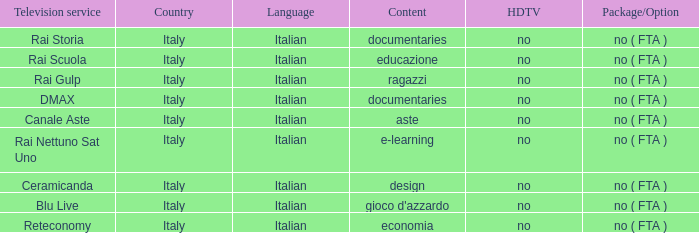What is the HDTV when documentaries are the content? No, no. 